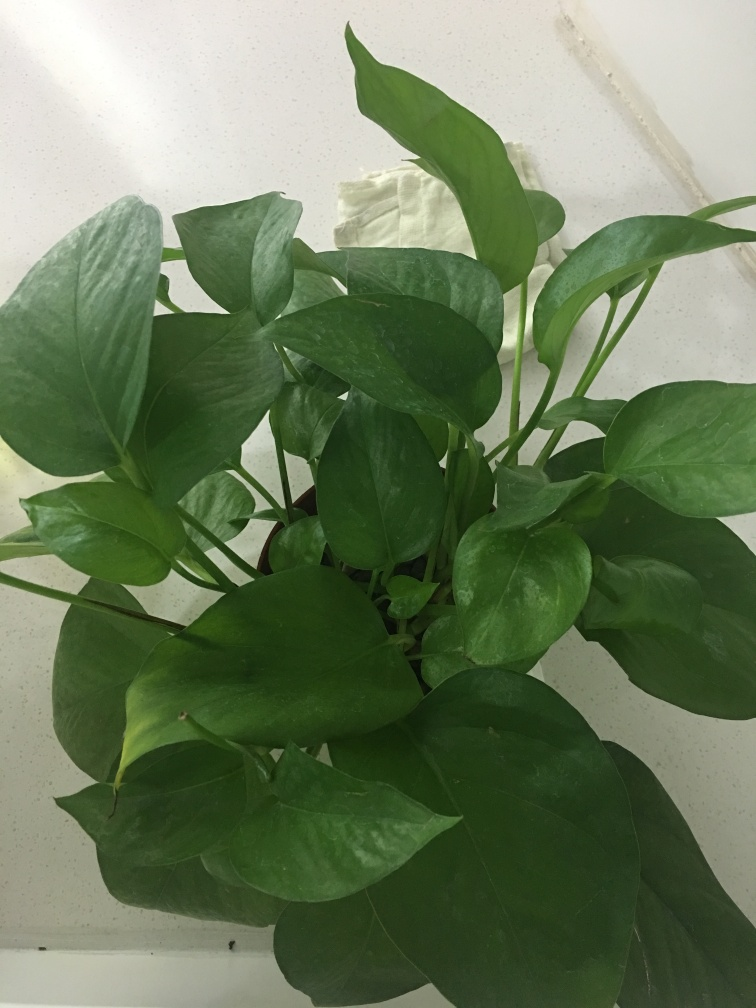Is the lighting sufficient in the image? The lighting in the image appears to be moderately sufficient. While the subject, which is a healthy green plant, is visible, the shadows indicate that the lighting could be more evenly distributed to highlight the plant's features better. Additional light sources could eliminate the shadows and enhance the visibility of the plant's texture and colors. 